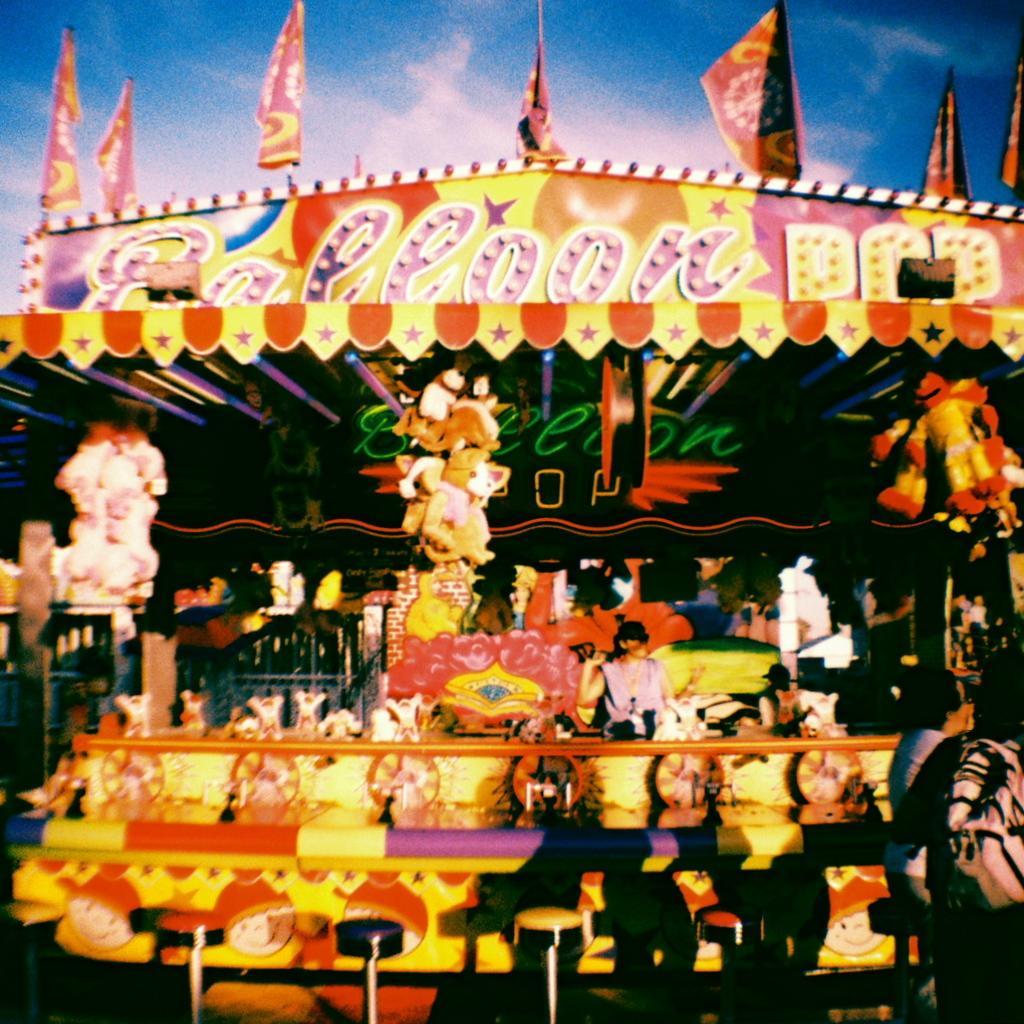Could you give a brief overview of what you see in this image? In this image we can see some people under a tent. We can also see some dolls, stools, a person sitting on a stool and some lights. On the backside we can see the flags and the sky which looks cloudy. 